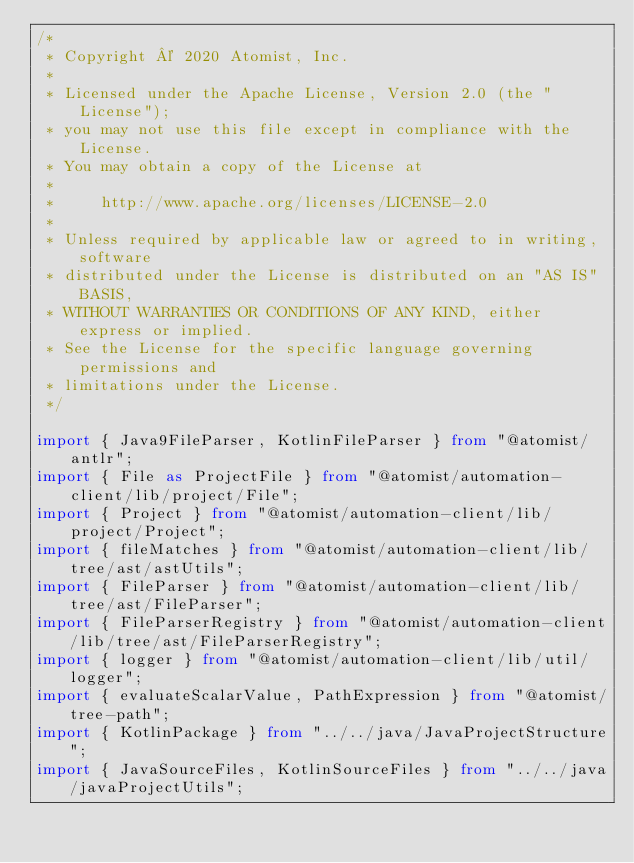Convert code to text. <code><loc_0><loc_0><loc_500><loc_500><_TypeScript_>/*
 * Copyright © 2020 Atomist, Inc.
 *
 * Licensed under the Apache License, Version 2.0 (the "License");
 * you may not use this file except in compliance with the License.
 * You may obtain a copy of the License at
 *
 *     http://www.apache.org/licenses/LICENSE-2.0
 *
 * Unless required by applicable law or agreed to in writing, software
 * distributed under the License is distributed on an "AS IS" BASIS,
 * WITHOUT WARRANTIES OR CONDITIONS OF ANY KIND, either express or implied.
 * See the License for the specific language governing permissions and
 * limitations under the License.
 */

import { Java9FileParser, KotlinFileParser } from "@atomist/antlr";
import { File as ProjectFile } from "@atomist/automation-client/lib/project/File";
import { Project } from "@atomist/automation-client/lib/project/Project";
import { fileMatches } from "@atomist/automation-client/lib/tree/ast/astUtils";
import { FileParser } from "@atomist/automation-client/lib/tree/ast/FileParser";
import { FileParserRegistry } from "@atomist/automation-client/lib/tree/ast/FileParserRegistry";
import { logger } from "@atomist/automation-client/lib/util/logger";
import { evaluateScalarValue, PathExpression } from "@atomist/tree-path";
import { KotlinPackage } from "../../java/JavaProjectStructure";
import { JavaSourceFiles, KotlinSourceFiles } from "../../java/javaProjectUtils";</code> 